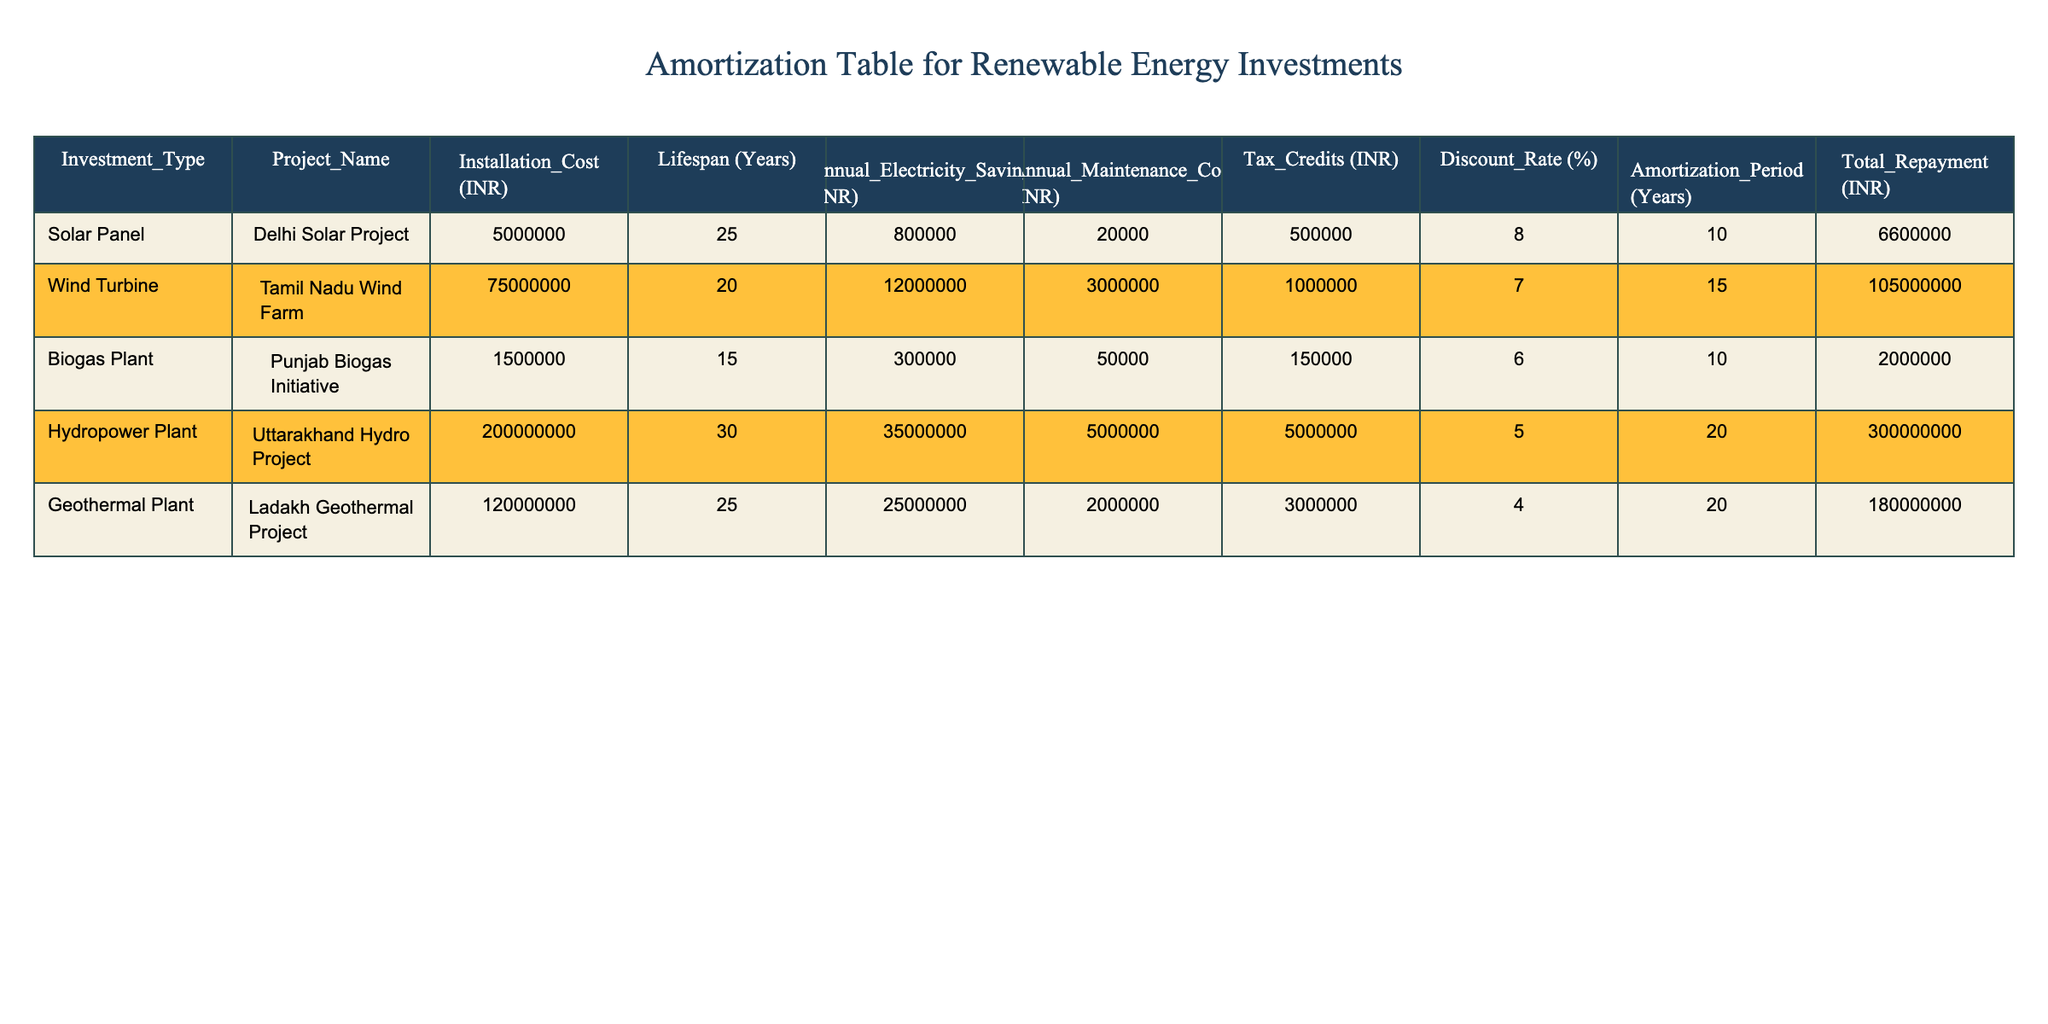What is the installation cost of the Tamil Nadu Wind Farm? The installation cost is listed directly in the table under the "Installation_Cost (INR)" column for the Tamil Nadu Wind Farm project. It shows 75000000 INR.
Answer: 75000000 INR What is the annual electricity savings of the Delhi Solar Project? The annual electricity savings figure is provided in the "Annual_Electricity_Savings (INR)" column for the Delhi Solar Project, which is stated as 800000 INR.
Answer: 800000 INR Is the annual maintenance cost higher for the Geothermal Plant than for the Biogas Plant? The table shows the annual maintenance cost for the Geothermal Plant as 2000000 INR and for the Biogas Plant as 50000 INR. Since 2000000 INR is greater than 50000 INR, the statement is true.
Answer: Yes How much total repayment will the Punjab Biogas Initiative require? The total repayment required for the Punjab Biogas Initiative is given in the "Total_Repayment (INR)" column. It shows that total repayment is 2000000 INR.
Answer: 2000000 INR Which project has the longest amortization period, and what is it? By examining the "Amortization_Period (Years)" column, the Uttarakhand Hydro Project has the longest amortization period listed as 20 years.
Answer: Uttarakhand Hydro Project, 20 years What is the average installation cost of all projects listed in the table? To find the average installation cost, sum all the installation costs: (5000000 + 75000000 + 1500000 + 200000000 + 120000000) = 382500000 INR. Then, divide by 5 (the number of projects), which gives 76500000 INR.
Answer: 76500000 INR Does the Delhi Solar Project have a discount rate lower than 6%? The discount rate for the Delhi Solar Project is stated as 8%, which is higher than 6%. Thus the statement is false.
Answer: No If we sum the annual maintenance costs for all projects, what is the total? Adding the annual maintenance costs: (20000 + 3000000 + 50000 + 5000000 + 2000000) = 10000000 INR gives the total annual maintenance cost across all projects as 10000000 INR.
Answer: 10000000 INR Is the annual electricity savings of the Wind Turbine project greater than the total repayment for the Punjab Biogas Initiative? The annual electricity savings for the Wind Turbine project is 12000000 INR, while the total repayment for the Punjab Biogas Initiative is 2000000 INR. Since 12000000 INR is greater than 2000000 INR, the answer is true.
Answer: Yes 